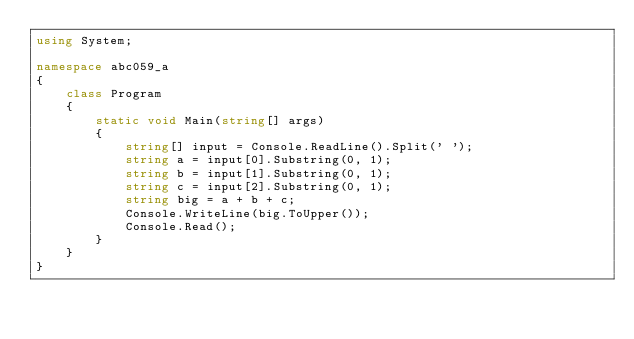Convert code to text. <code><loc_0><loc_0><loc_500><loc_500><_C#_>using System;

namespace abc059_a
{
    class Program
    {
        static void Main(string[] args)
        {
            string[] input = Console.ReadLine().Split(' ');
            string a = input[0].Substring(0, 1);
            string b = input[1].Substring(0, 1);
            string c = input[2].Substring(0, 1);
            string big = a + b + c;
            Console.WriteLine(big.ToUpper());
            Console.Read();
        }
    }
}
</code> 